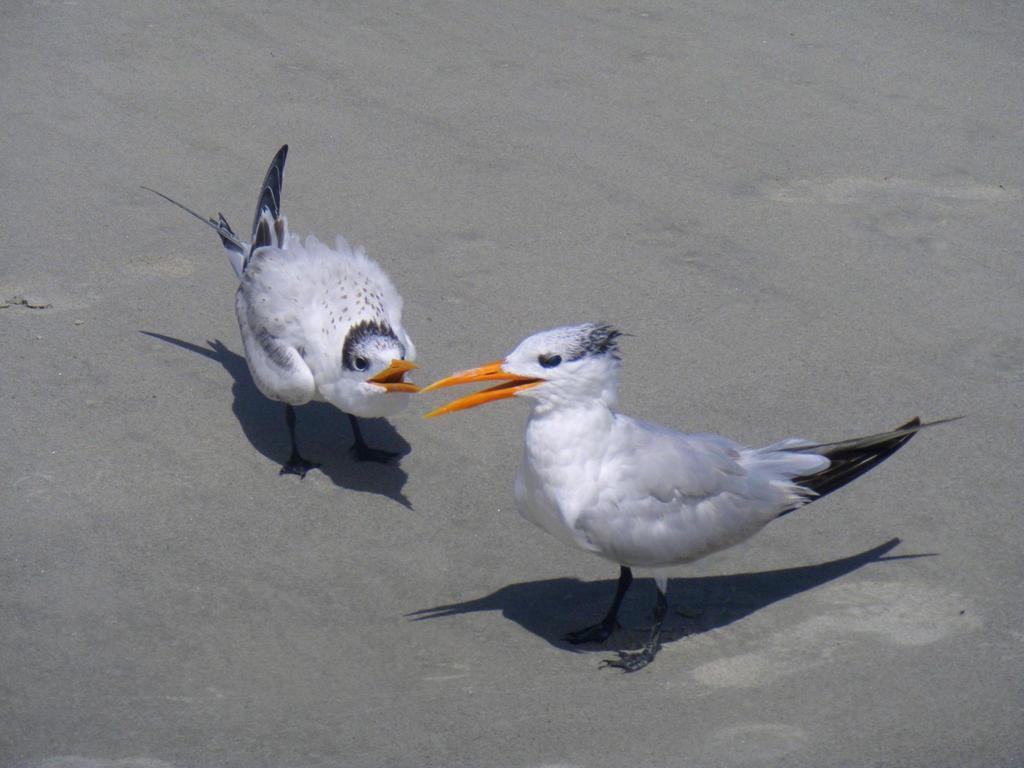Could you give a brief overview of what you see in this image? In this image I can see two birds standing on the ash color surface. These birds are in white, black and orange color. 